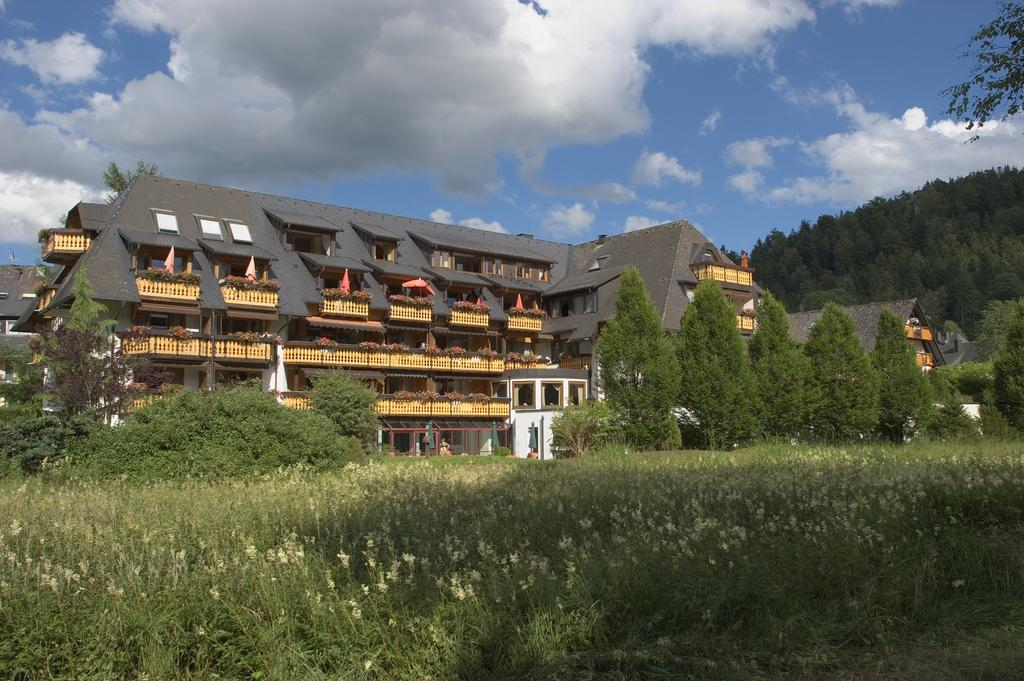What types of vegetation are at the bottom of the image? There are plants and flowers at the bottom of the image. What structures can be seen in the center of the image? There are buildings and trees in the center of the image. What is visible at the top of the image? The sky is visible at the top of the image. Can you see any signs of peace in the image? The concept of peace is not directly observable in the image, as it features plants, flowers, buildings, trees, and the sky. Are there any nails visible in the image? There are no nails present in the image. 